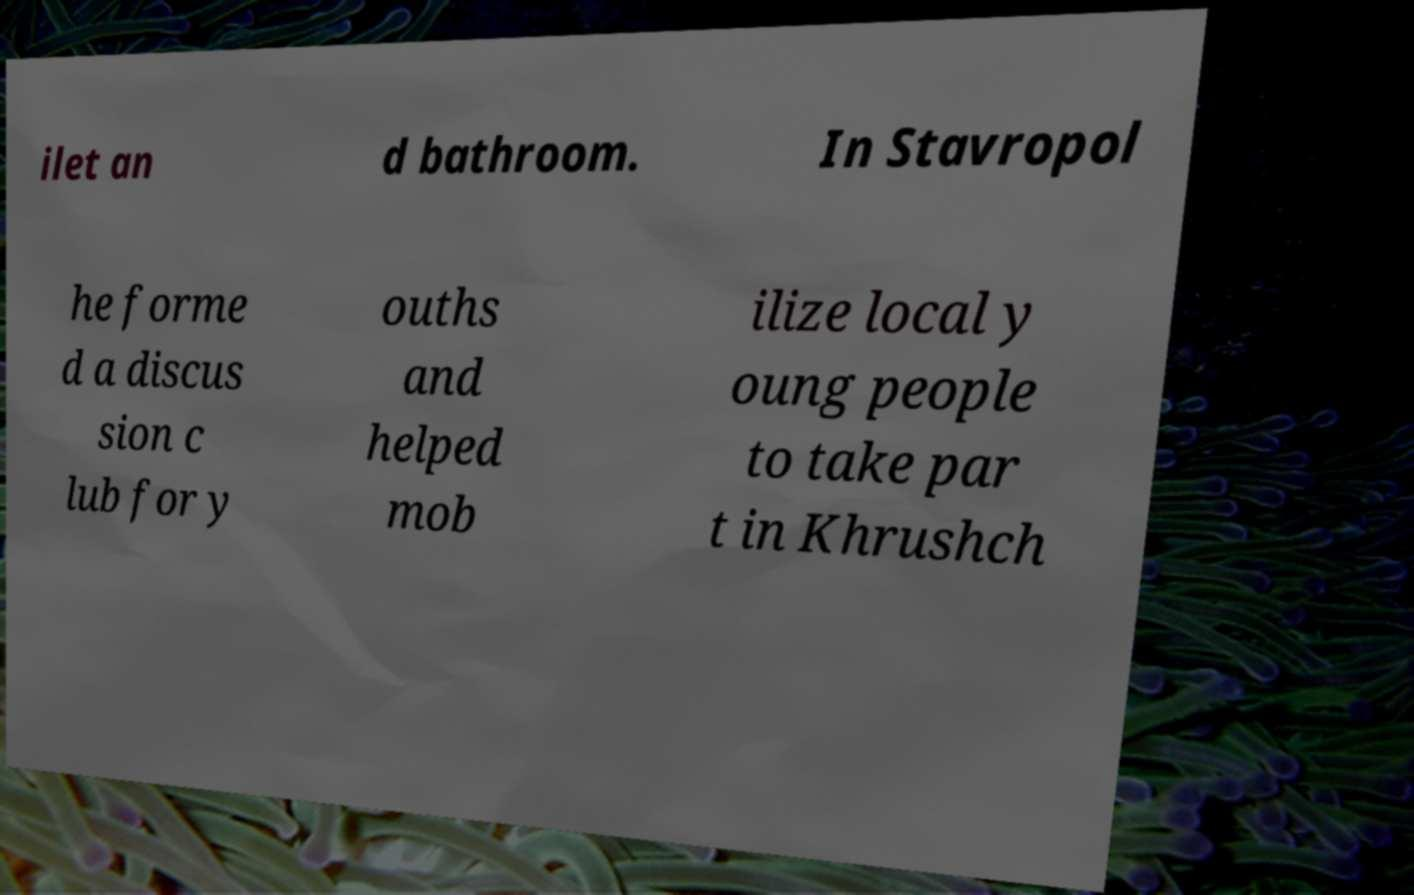Could you extract and type out the text from this image? ilet an d bathroom. In Stavropol he forme d a discus sion c lub for y ouths and helped mob ilize local y oung people to take par t in Khrushch 